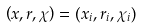<formula> <loc_0><loc_0><loc_500><loc_500>\left ( x , r , \chi \right ) = ( x _ { i } , r _ { i } , \chi _ { i } )</formula> 